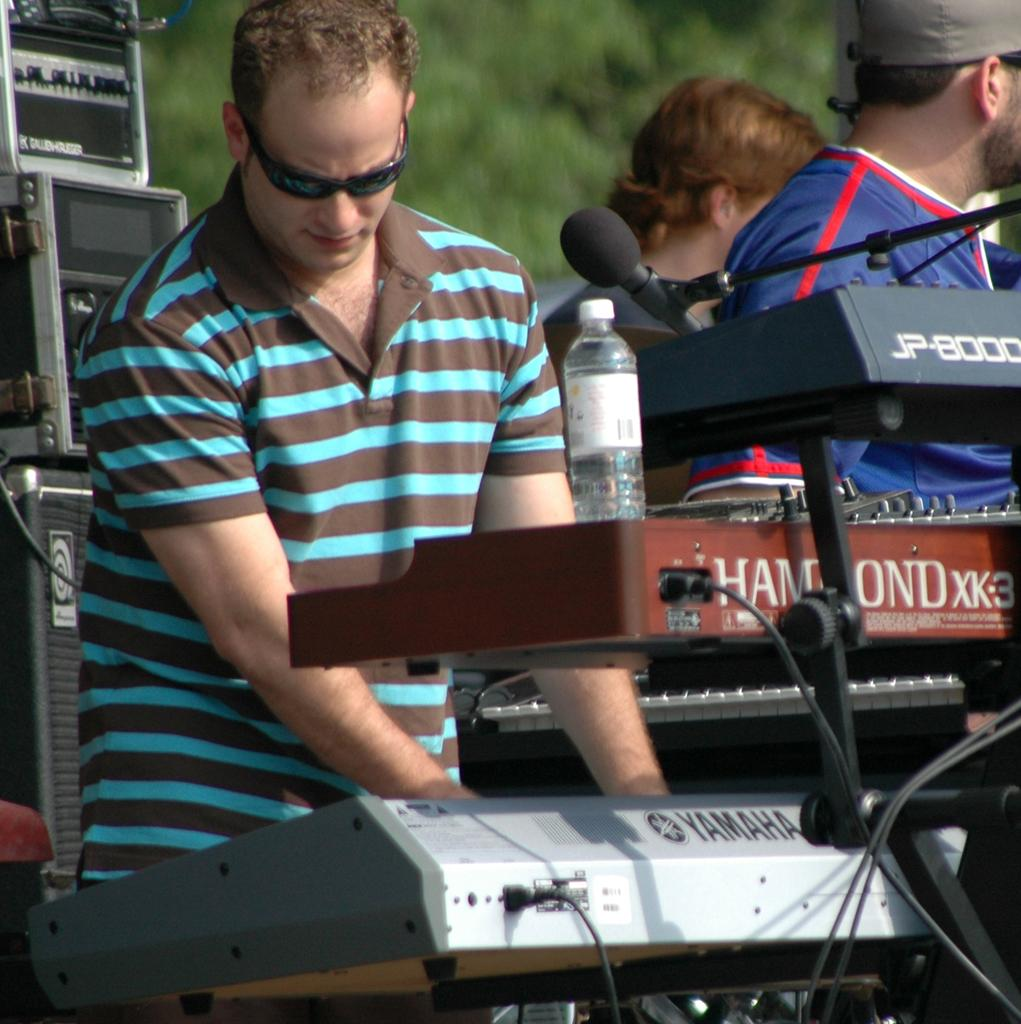What is the person in the image doing? The person in the image is playing a keyboard. What is in front of the person? There is a microphone and a bottle of water in front of the person. Can you describe the people behind the person? There are two people behind the person. What can be used to amplify sound in the image? There are speakers visible in the image. What is visible in the background of the image? There are trees in the background of the image. What type of bedroom furniture can be seen in the image? There is no bedroom furniture present in the image. How does the person grip the keyboard while playing? The image does not show the person's grip on the keyboard, so it cannot be determined from the image. 